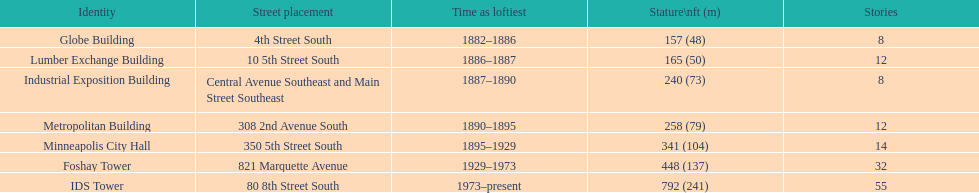How many buildings on the list are taller than 200 feet? 5. 